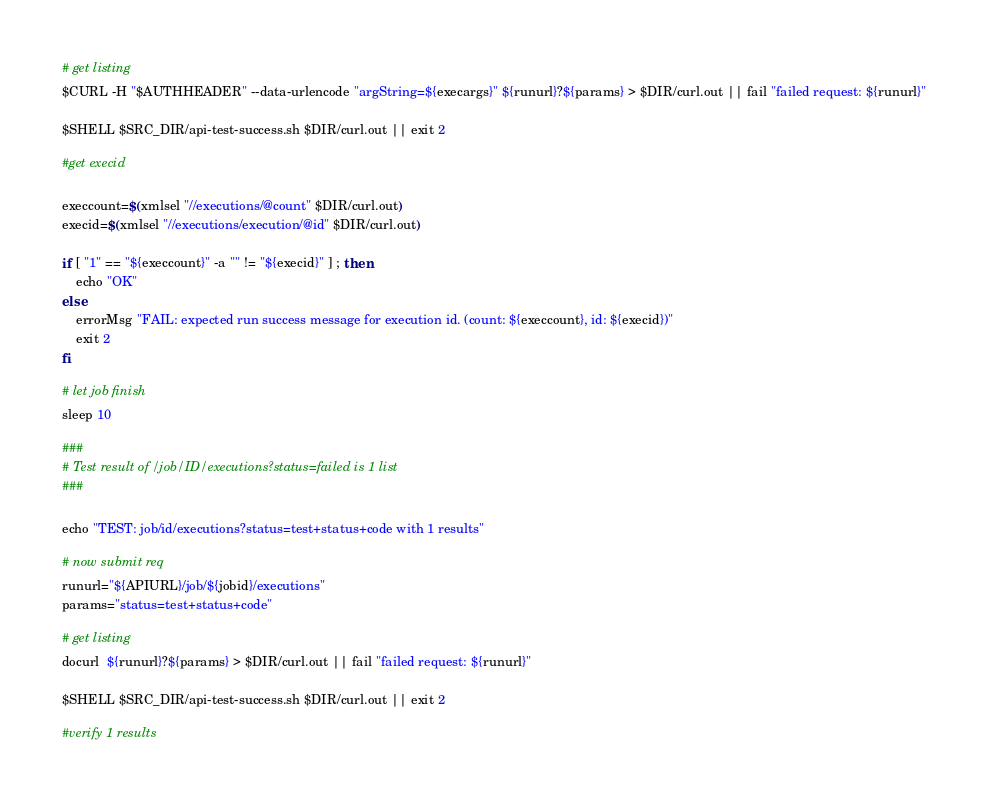<code> <loc_0><loc_0><loc_500><loc_500><_Bash_>
# get listing
$CURL -H "$AUTHHEADER" --data-urlencode "argString=${execargs}" ${runurl}?${params} > $DIR/curl.out || fail "failed request: ${runurl}"

$SHELL $SRC_DIR/api-test-success.sh $DIR/curl.out || exit 2

#get execid

execcount=$(xmlsel "//executions/@count" $DIR/curl.out)
execid=$(xmlsel "//executions/execution/@id" $DIR/curl.out)

if [ "1" == "${execcount}" -a "" != "${execid}" ] ; then
    echo "OK"
else
    errorMsg "FAIL: expected run success message for execution id. (count: ${execcount}, id: ${execid})"
    exit 2
fi

# let job finish
sleep 10

###
# Test result of /job/ID/executions?status=failed is 1 list
###

echo "TEST: job/id/executions?status=test+status+code with 1 results"

# now submit req
runurl="${APIURL}/job/${jobid}/executions"
params="status=test+status+code"

# get listing
docurl  ${runurl}?${params} > $DIR/curl.out || fail "failed request: ${runurl}"

$SHELL $SRC_DIR/api-test-success.sh $DIR/curl.out || exit 2

#verify 1 results
</code> 